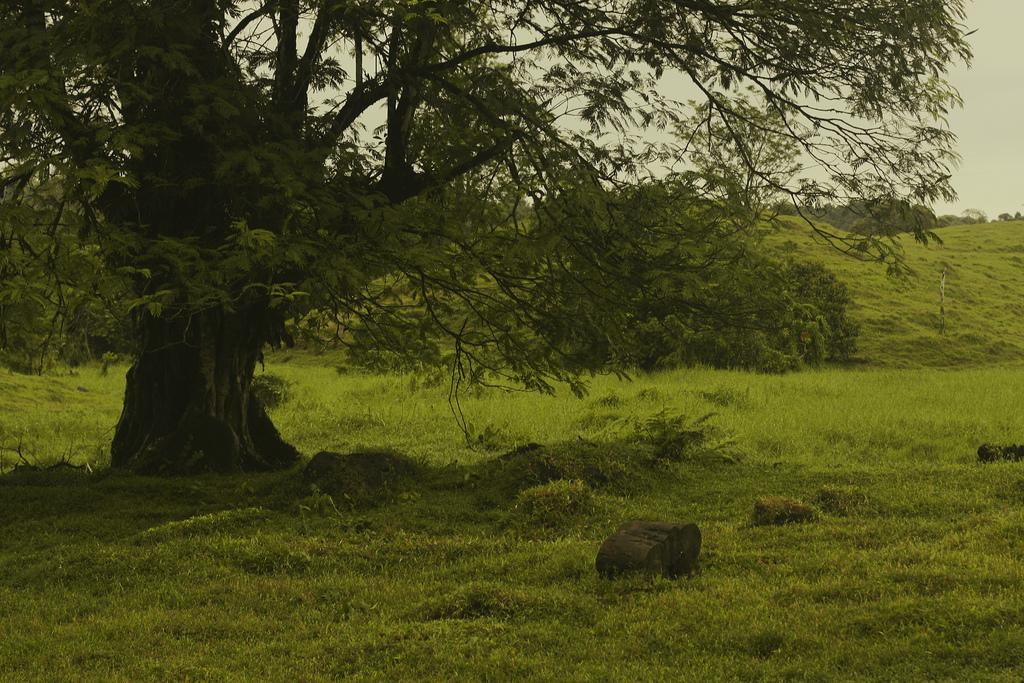What type of surface is visible in the image? There is a grass surface in the image. What other objects can be seen on the grass surface? There are rocks visible on the grass surface. What type of plant is present in the image? There is a tree in the image. Can you describe the background of the image? There is another tree visible in the background of the image, along with the sky. What type of health benefits can be gained from the hydrant in the image? There is no hydrant present in the image, so it is not possible to discuss any health benefits related to it. 